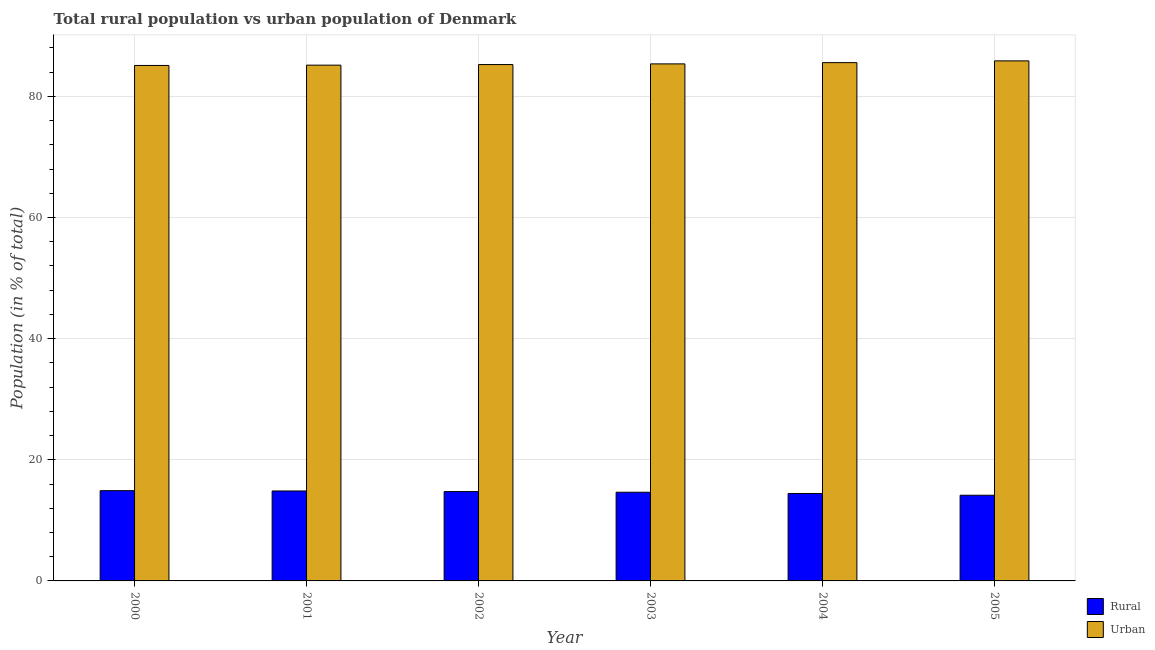Are the number of bars on each tick of the X-axis equal?
Keep it short and to the point. Yes. How many bars are there on the 5th tick from the left?
Give a very brief answer. 2. How many bars are there on the 6th tick from the right?
Provide a short and direct response. 2. What is the label of the 1st group of bars from the left?
Provide a succinct answer. 2000. What is the urban population in 2002?
Make the answer very short. 85.25. Across all years, what is the maximum urban population?
Your answer should be compact. 85.86. Across all years, what is the minimum rural population?
Your answer should be very brief. 14.14. In which year was the rural population minimum?
Your answer should be compact. 2005. What is the total rural population in the graph?
Ensure brevity in your answer.  87.72. What is the difference between the urban population in 2003 and that in 2004?
Your answer should be very brief. -0.21. What is the difference between the urban population in 2001 and the rural population in 2004?
Your answer should be very brief. -0.42. What is the average urban population per year?
Provide a short and direct response. 85.38. What is the ratio of the urban population in 2003 to that in 2005?
Your answer should be compact. 0.99. Is the difference between the rural population in 2002 and 2004 greater than the difference between the urban population in 2002 and 2004?
Provide a succinct answer. No. What is the difference between the highest and the second highest urban population?
Keep it short and to the point. 0.29. What is the difference between the highest and the lowest rural population?
Keep it short and to the point. 0.76. In how many years, is the rural population greater than the average rural population taken over all years?
Ensure brevity in your answer.  4. What does the 1st bar from the left in 2000 represents?
Keep it short and to the point. Rural. What does the 2nd bar from the right in 2003 represents?
Provide a succinct answer. Rural. How many bars are there?
Keep it short and to the point. 12. Are all the bars in the graph horizontal?
Make the answer very short. No. How many years are there in the graph?
Keep it short and to the point. 6. What is the difference between two consecutive major ticks on the Y-axis?
Offer a very short reply. 20. Are the values on the major ticks of Y-axis written in scientific E-notation?
Your answer should be compact. No. Does the graph contain any zero values?
Your response must be concise. No. Where does the legend appear in the graph?
Your answer should be very brief. Bottom right. How many legend labels are there?
Your answer should be very brief. 2. What is the title of the graph?
Ensure brevity in your answer.  Total rural population vs urban population of Denmark. Does "Death rate" appear as one of the legend labels in the graph?
Make the answer very short. No. What is the label or title of the X-axis?
Give a very brief answer. Year. What is the label or title of the Y-axis?
Offer a very short reply. Population (in % of total). What is the Population (in % of total) in Rural in 2000?
Your answer should be very brief. 14.9. What is the Population (in % of total) of Urban in 2000?
Offer a very short reply. 85.1. What is the Population (in % of total) in Rural in 2001?
Give a very brief answer. 14.85. What is the Population (in % of total) in Urban in 2001?
Provide a short and direct response. 85.15. What is the Population (in % of total) in Rural in 2002?
Provide a succinct answer. 14.75. What is the Population (in % of total) of Urban in 2002?
Your response must be concise. 85.25. What is the Population (in % of total) of Rural in 2003?
Offer a very short reply. 14.64. What is the Population (in % of total) of Urban in 2003?
Provide a short and direct response. 85.36. What is the Population (in % of total) of Rural in 2004?
Ensure brevity in your answer.  14.43. What is the Population (in % of total) of Urban in 2004?
Your answer should be very brief. 85.57. What is the Population (in % of total) in Rural in 2005?
Offer a terse response. 14.14. What is the Population (in % of total) in Urban in 2005?
Offer a very short reply. 85.86. Across all years, what is the maximum Population (in % of total) in Urban?
Offer a very short reply. 85.86. Across all years, what is the minimum Population (in % of total) of Rural?
Keep it short and to the point. 14.14. Across all years, what is the minimum Population (in % of total) in Urban?
Provide a succinct answer. 85.1. What is the total Population (in % of total) in Rural in the graph?
Make the answer very short. 87.72. What is the total Population (in % of total) of Urban in the graph?
Your answer should be compact. 512.28. What is the difference between the Population (in % of total) of Rural in 2000 and that in 2001?
Provide a succinct answer. 0.05. What is the difference between the Population (in % of total) in Urban in 2000 and that in 2001?
Offer a terse response. -0.05. What is the difference between the Population (in % of total) in Urban in 2000 and that in 2002?
Make the answer very short. -0.15. What is the difference between the Population (in % of total) in Rural in 2000 and that in 2003?
Your answer should be very brief. 0.26. What is the difference between the Population (in % of total) of Urban in 2000 and that in 2003?
Make the answer very short. -0.26. What is the difference between the Population (in % of total) in Rural in 2000 and that in 2004?
Offer a very short reply. 0.47. What is the difference between the Population (in % of total) of Urban in 2000 and that in 2004?
Make the answer very short. -0.47. What is the difference between the Population (in % of total) in Rural in 2000 and that in 2005?
Your response must be concise. 0.76. What is the difference between the Population (in % of total) in Urban in 2000 and that in 2005?
Offer a very short reply. -0.76. What is the difference between the Population (in % of total) of Rural in 2001 and that in 2002?
Ensure brevity in your answer.  0.1. What is the difference between the Population (in % of total) of Urban in 2001 and that in 2002?
Your answer should be very brief. -0.1. What is the difference between the Population (in % of total) in Rural in 2001 and that in 2003?
Make the answer very short. 0.21. What is the difference between the Population (in % of total) of Urban in 2001 and that in 2003?
Offer a terse response. -0.21. What is the difference between the Population (in % of total) in Rural in 2001 and that in 2004?
Provide a short and direct response. 0.42. What is the difference between the Population (in % of total) in Urban in 2001 and that in 2004?
Your answer should be very brief. -0.42. What is the difference between the Population (in % of total) of Rural in 2001 and that in 2005?
Keep it short and to the point. 0.71. What is the difference between the Population (in % of total) of Urban in 2001 and that in 2005?
Give a very brief answer. -0.71. What is the difference between the Population (in % of total) in Rural in 2002 and that in 2003?
Provide a succinct answer. 0.11. What is the difference between the Population (in % of total) of Urban in 2002 and that in 2003?
Keep it short and to the point. -0.11. What is the difference between the Population (in % of total) of Rural in 2002 and that in 2004?
Keep it short and to the point. 0.32. What is the difference between the Population (in % of total) in Urban in 2002 and that in 2004?
Keep it short and to the point. -0.32. What is the difference between the Population (in % of total) in Rural in 2002 and that in 2005?
Offer a terse response. 0.61. What is the difference between the Population (in % of total) of Urban in 2002 and that in 2005?
Offer a very short reply. -0.61. What is the difference between the Population (in % of total) in Rural in 2003 and that in 2004?
Keep it short and to the point. 0.21. What is the difference between the Population (in % of total) in Urban in 2003 and that in 2004?
Give a very brief answer. -0.21. What is the difference between the Population (in % of total) of Rural in 2003 and that in 2005?
Offer a very short reply. 0.5. What is the difference between the Population (in % of total) of Urban in 2003 and that in 2005?
Ensure brevity in your answer.  -0.5. What is the difference between the Population (in % of total) of Rural in 2004 and that in 2005?
Your response must be concise. 0.29. What is the difference between the Population (in % of total) in Urban in 2004 and that in 2005?
Provide a succinct answer. -0.29. What is the difference between the Population (in % of total) in Rural in 2000 and the Population (in % of total) in Urban in 2001?
Make the answer very short. -70.25. What is the difference between the Population (in % of total) in Rural in 2000 and the Population (in % of total) in Urban in 2002?
Ensure brevity in your answer.  -70.35. What is the difference between the Population (in % of total) of Rural in 2000 and the Population (in % of total) of Urban in 2003?
Offer a very short reply. -70.46. What is the difference between the Population (in % of total) in Rural in 2000 and the Population (in % of total) in Urban in 2004?
Give a very brief answer. -70.67. What is the difference between the Population (in % of total) in Rural in 2000 and the Population (in % of total) in Urban in 2005?
Offer a terse response. -70.96. What is the difference between the Population (in % of total) in Rural in 2001 and the Population (in % of total) in Urban in 2002?
Make the answer very short. -70.4. What is the difference between the Population (in % of total) in Rural in 2001 and the Population (in % of total) in Urban in 2003?
Your answer should be very brief. -70.51. What is the difference between the Population (in % of total) of Rural in 2001 and the Population (in % of total) of Urban in 2004?
Provide a succinct answer. -70.72. What is the difference between the Population (in % of total) of Rural in 2001 and the Population (in % of total) of Urban in 2005?
Give a very brief answer. -71.01. What is the difference between the Population (in % of total) in Rural in 2002 and the Population (in % of total) in Urban in 2003?
Make the answer very short. -70.61. What is the difference between the Population (in % of total) in Rural in 2002 and the Population (in % of total) in Urban in 2004?
Provide a succinct answer. -70.82. What is the difference between the Population (in % of total) of Rural in 2002 and the Population (in % of total) of Urban in 2005?
Provide a succinct answer. -71.11. What is the difference between the Population (in % of total) in Rural in 2003 and the Population (in % of total) in Urban in 2004?
Give a very brief answer. -70.93. What is the difference between the Population (in % of total) in Rural in 2003 and the Population (in % of total) in Urban in 2005?
Your response must be concise. -71.22. What is the difference between the Population (in % of total) of Rural in 2004 and the Population (in % of total) of Urban in 2005?
Offer a very short reply. -71.42. What is the average Population (in % of total) of Rural per year?
Offer a very short reply. 14.62. What is the average Population (in % of total) in Urban per year?
Offer a very short reply. 85.38. In the year 2000, what is the difference between the Population (in % of total) in Rural and Population (in % of total) in Urban?
Ensure brevity in your answer.  -70.2. In the year 2001, what is the difference between the Population (in % of total) in Rural and Population (in % of total) in Urban?
Offer a terse response. -70.3. In the year 2002, what is the difference between the Population (in % of total) of Rural and Population (in % of total) of Urban?
Provide a short and direct response. -70.5. In the year 2003, what is the difference between the Population (in % of total) of Rural and Population (in % of total) of Urban?
Your answer should be very brief. -70.72. In the year 2004, what is the difference between the Population (in % of total) of Rural and Population (in % of total) of Urban?
Your answer should be compact. -71.13. In the year 2005, what is the difference between the Population (in % of total) of Rural and Population (in % of total) of Urban?
Your answer should be compact. -71.71. What is the ratio of the Population (in % of total) of Rural in 2000 to that in 2002?
Offer a very short reply. 1.01. What is the ratio of the Population (in % of total) in Rural in 2000 to that in 2003?
Ensure brevity in your answer.  1.02. What is the ratio of the Population (in % of total) of Urban in 2000 to that in 2003?
Make the answer very short. 1. What is the ratio of the Population (in % of total) of Rural in 2000 to that in 2004?
Your answer should be very brief. 1.03. What is the ratio of the Population (in % of total) of Rural in 2000 to that in 2005?
Your answer should be very brief. 1.05. What is the ratio of the Population (in % of total) in Rural in 2001 to that in 2002?
Keep it short and to the point. 1.01. What is the ratio of the Population (in % of total) of Rural in 2001 to that in 2003?
Ensure brevity in your answer.  1.01. What is the ratio of the Population (in % of total) in Rural in 2001 to that in 2004?
Your answer should be very brief. 1.03. What is the ratio of the Population (in % of total) in Urban in 2001 to that in 2004?
Your answer should be very brief. 1. What is the ratio of the Population (in % of total) in Rural in 2001 to that in 2005?
Ensure brevity in your answer.  1.05. What is the ratio of the Population (in % of total) in Urban in 2001 to that in 2005?
Your response must be concise. 0.99. What is the ratio of the Population (in % of total) of Rural in 2002 to that in 2003?
Offer a terse response. 1.01. What is the ratio of the Population (in % of total) of Rural in 2002 to that in 2004?
Your response must be concise. 1.02. What is the ratio of the Population (in % of total) of Urban in 2002 to that in 2004?
Your answer should be compact. 1. What is the ratio of the Population (in % of total) in Rural in 2002 to that in 2005?
Your answer should be compact. 1.04. What is the ratio of the Population (in % of total) of Rural in 2003 to that in 2004?
Your response must be concise. 1.01. What is the ratio of the Population (in % of total) in Urban in 2003 to that in 2004?
Give a very brief answer. 1. What is the ratio of the Population (in % of total) in Rural in 2003 to that in 2005?
Make the answer very short. 1.04. What is the ratio of the Population (in % of total) of Urban in 2003 to that in 2005?
Provide a short and direct response. 0.99. What is the ratio of the Population (in % of total) of Rural in 2004 to that in 2005?
Offer a very short reply. 1.02. What is the ratio of the Population (in % of total) in Urban in 2004 to that in 2005?
Make the answer very short. 1. What is the difference between the highest and the second highest Population (in % of total) of Rural?
Your answer should be compact. 0.05. What is the difference between the highest and the second highest Population (in % of total) in Urban?
Make the answer very short. 0.29. What is the difference between the highest and the lowest Population (in % of total) in Rural?
Make the answer very short. 0.76. What is the difference between the highest and the lowest Population (in % of total) in Urban?
Offer a very short reply. 0.76. 